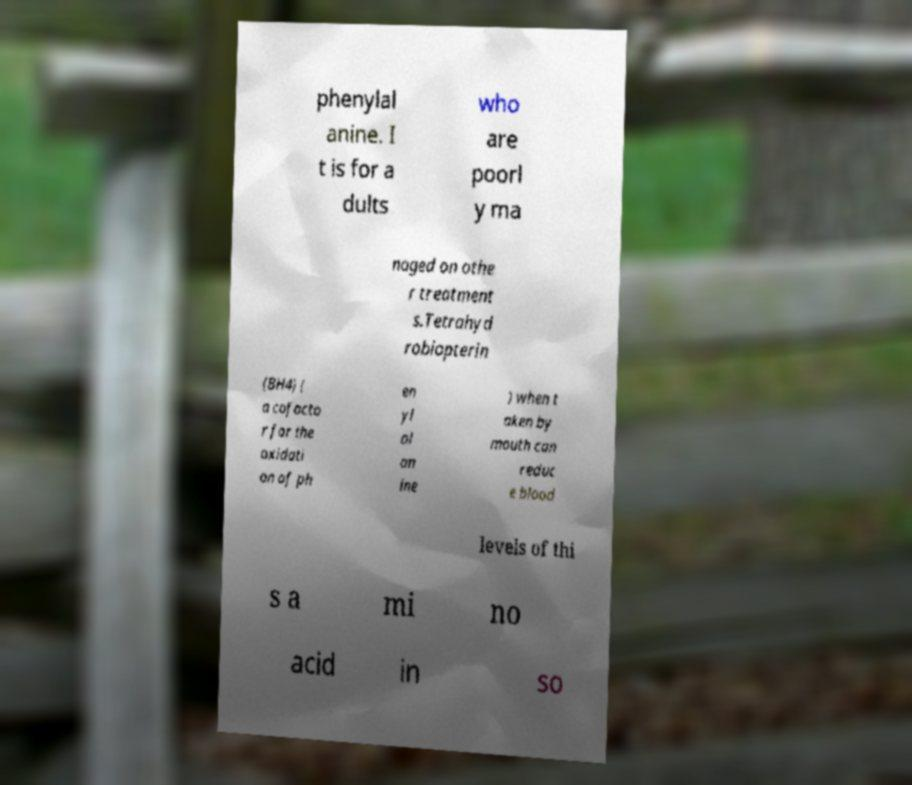For documentation purposes, I need the text within this image transcribed. Could you provide that? phenylal anine. I t is for a dults who are poorl y ma naged on othe r treatment s.Tetrahyd robiopterin (BH4) ( a cofacto r for the oxidati on of ph en yl al an ine ) when t aken by mouth can reduc e blood levels of thi s a mi no acid in so 